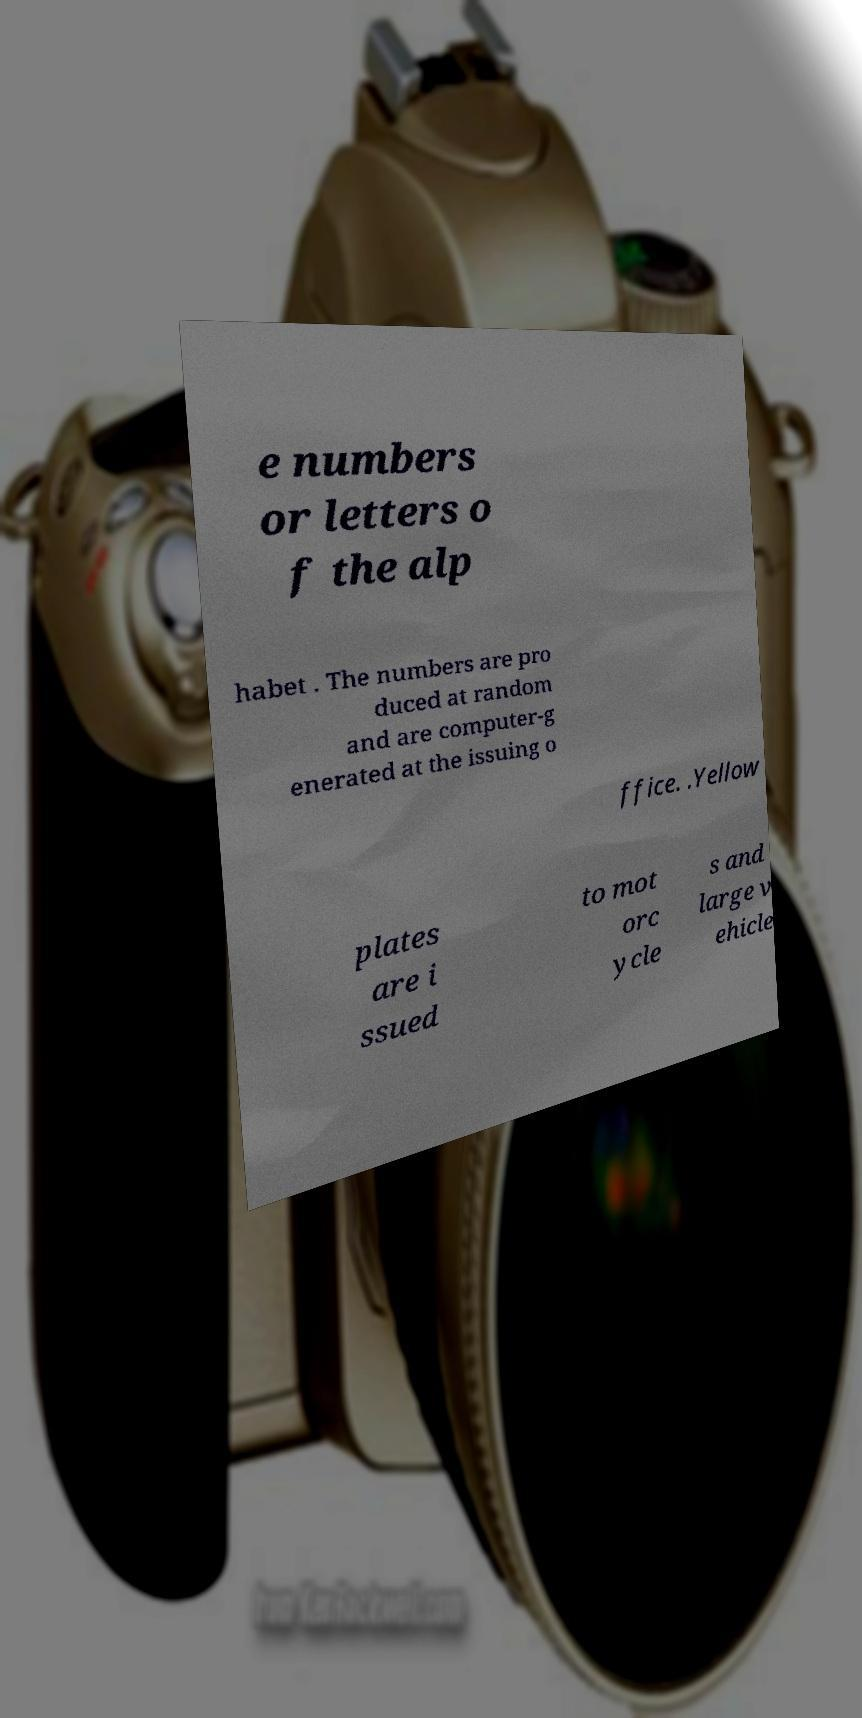For documentation purposes, I need the text within this image transcribed. Could you provide that? e numbers or letters o f the alp habet . The numbers are pro duced at random and are computer-g enerated at the issuing o ffice. .Yellow plates are i ssued to mot orc ycle s and large v ehicle 